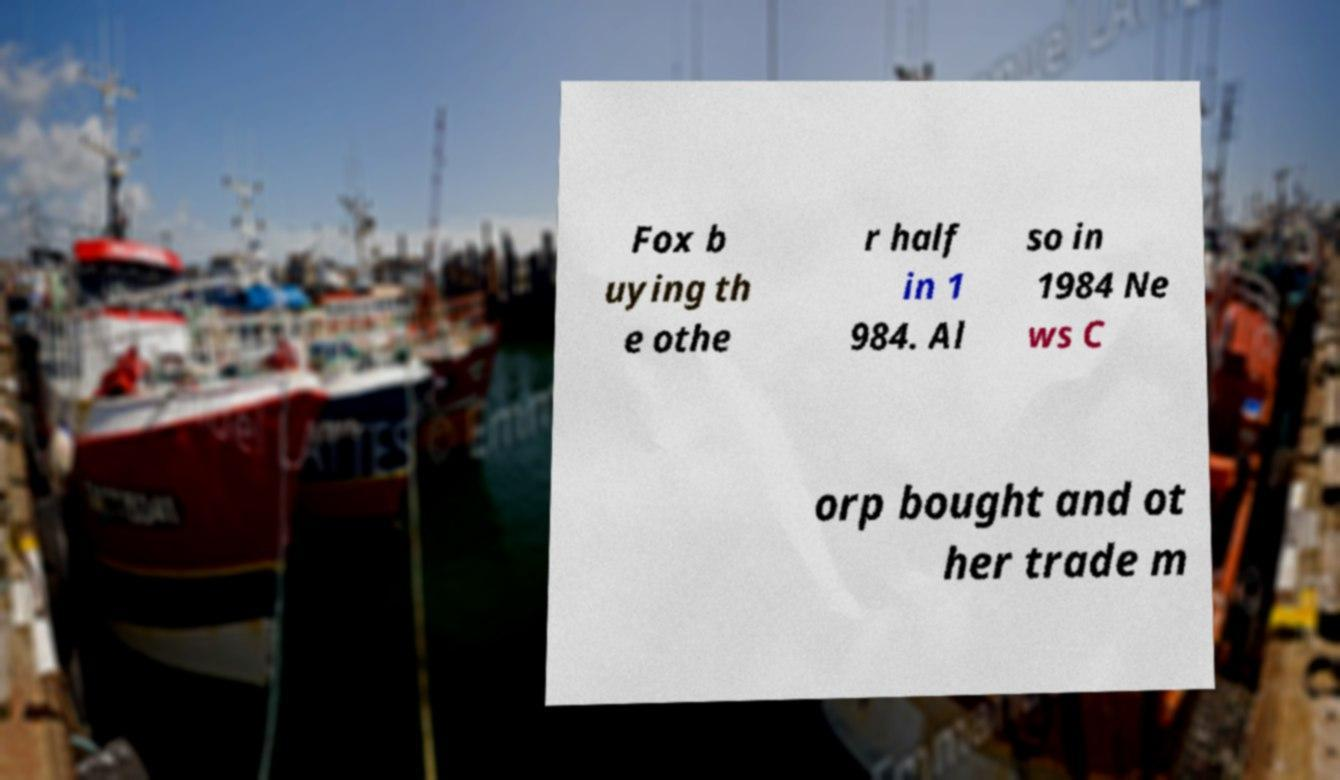What messages or text are displayed in this image? I need them in a readable, typed format. Fox b uying th e othe r half in 1 984. Al so in 1984 Ne ws C orp bought and ot her trade m 